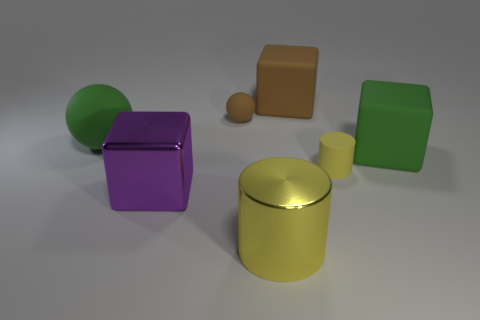Are there fewer green matte cubes right of the green block than big purple objects that are on the right side of the big green ball? While examining the image, it's clear that there is one green matte cube to the right of the green block, and there is one large purple cube to the right side of the big green ball. Therefore, the number of green matte cubes right of the green block is equal to the number of big purple objects on the right side of the green ball, namely one of each. 